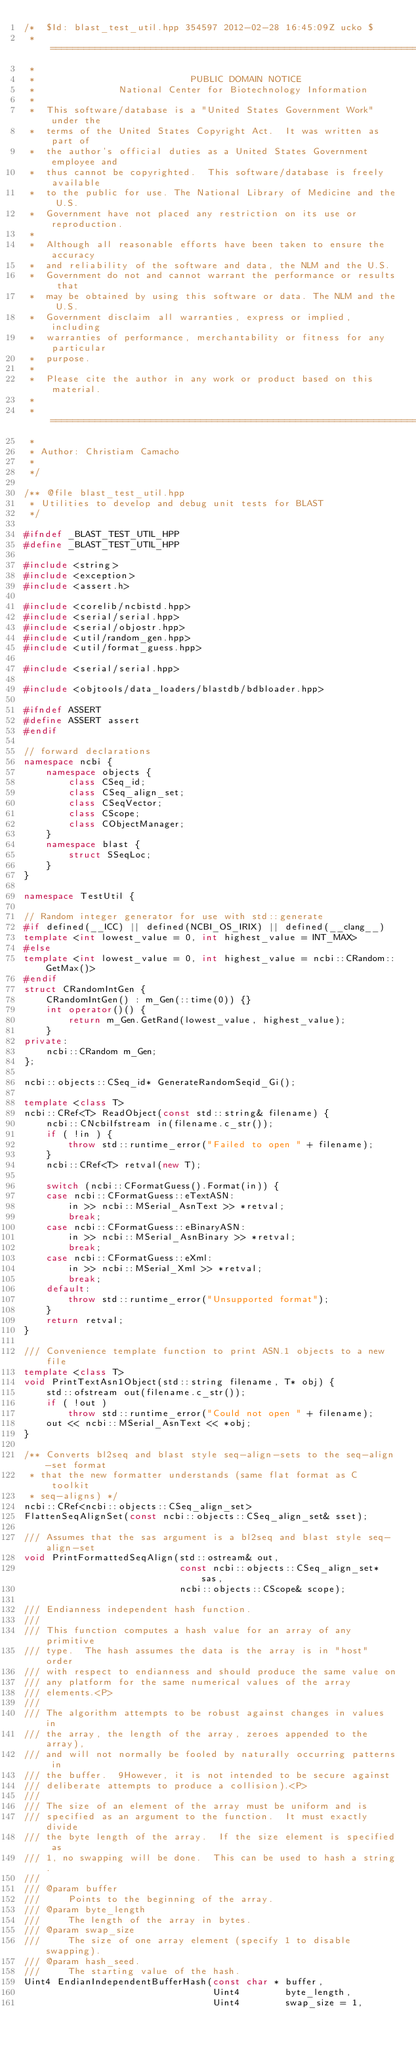Convert code to text. <code><loc_0><loc_0><loc_500><loc_500><_C++_>/*  $Id: blast_test_util.hpp 354597 2012-02-28 16:45:09Z ucko $
 * ===========================================================================
 *
 *                            PUBLIC DOMAIN NOTICE
 *               National Center for Biotechnology Information
 *
 *  This software/database is a "United States Government Work" under the
 *  terms of the United States Copyright Act.  It was written as part of
 *  the author's official duties as a United States Government employee and
 *  thus cannot be copyrighted.  This software/database is freely available
 *  to the public for use. The National Library of Medicine and the U.S.
 *  Government have not placed any restriction on its use or reproduction.
 *
 *  Although all reasonable efforts have been taken to ensure the accuracy
 *  and reliability of the software and data, the NLM and the U.S.
 *  Government do not and cannot warrant the performance or results that
 *  may be obtained by using this software or data. The NLM and the U.S.
 *  Government disclaim all warranties, express or implied, including
 *  warranties of performance, merchantability or fitness for any particular
 *  purpose.
 *
 *  Please cite the author in any work or product based on this material.
 *
 * ===========================================================================
 *
 * Author: Christiam Camacho
 *
 */

/** @file blast_test_util.hpp
 * Utilities to develop and debug unit tests for BLAST
 */

#ifndef _BLAST_TEST_UTIL_HPP
#define _BLAST_TEST_UTIL_HPP

#include <string>
#include <exception>
#include <assert.h>

#include <corelib/ncbistd.hpp>
#include <serial/serial.hpp>
#include <serial/objostr.hpp>
#include <util/random_gen.hpp>
#include <util/format_guess.hpp>

#include <serial/serial.hpp>

#include <objtools/data_loaders/blastdb/bdbloader.hpp>

#ifndef ASSERT
#define ASSERT assert
#endif

// forward declarations
namespace ncbi {
    namespace objects {
        class CSeq_id;
        class CSeq_align_set;
        class CSeqVector;
        class CScope;
        class CObjectManager;
    }
    namespace blast {
        struct SSeqLoc;
    }
}

namespace TestUtil {

// Random integer generator for use with std::generate
#if defined(__ICC) || defined(NCBI_OS_IRIX) || defined(__clang__)
template <int lowest_value = 0, int highest_value = INT_MAX>
#else
template <int lowest_value = 0, int highest_value = ncbi::CRandom::GetMax()>
#endif
struct CRandomIntGen {
    CRandomIntGen() : m_Gen(::time(0)) {}
    int operator()() {
        return m_Gen.GetRand(lowest_value, highest_value);
    }
private:
    ncbi::CRandom m_Gen;
};

ncbi::objects::CSeq_id* GenerateRandomSeqid_Gi();

template <class T>
ncbi::CRef<T> ReadObject(const std::string& filename) {
    ncbi::CNcbiIfstream in(filename.c_str()); 
    if ( !in ) {
        throw std::runtime_error("Failed to open " + filename);
    }
    ncbi::CRef<T> retval(new T);

    switch (ncbi::CFormatGuess().Format(in)) {
    case ncbi::CFormatGuess::eTextASN:
        in >> ncbi::MSerial_AsnText >> *retval;
        break;
    case ncbi::CFormatGuess::eBinaryASN:
        in >> ncbi::MSerial_AsnBinary >> *retval;
        break;
    case ncbi::CFormatGuess::eXml:
        in >> ncbi::MSerial_Xml >> *retval;
        break;
    default:
        throw std::runtime_error("Unsupported format");
    }
    return retval;
}

/// Convenience template function to print ASN.1 objects to a new file
template <class T>
void PrintTextAsn1Object(std::string filename, T* obj) {
    std::ofstream out(filename.c_str());
    if ( !out )
        throw std::runtime_error("Could not open " + filename);
    out << ncbi::MSerial_AsnText << *obj;
}

/** Converts bl2seq and blast style seq-align-sets to the seq-align-set format
 * that the new formatter understands (same flat format as C toolkit
 * seq-aligns) */
ncbi::CRef<ncbi::objects::CSeq_align_set>
FlattenSeqAlignSet(const ncbi::objects::CSeq_align_set& sset);

/// Assumes that the sas argument is a bl2seq and blast style seq-align-set
void PrintFormattedSeqAlign(std::ostream& out,
                            const ncbi::objects::CSeq_align_set* sas,
                            ncbi::objects::CScope& scope);

/// Endianness independent hash function.
///
/// This function computes a hash value for an array of any primitive
/// type.  The hash assumes the data is the array is in "host" order
/// with respect to endianness and should produce the same value on
/// any platform for the same numerical values of the array
/// elements.<P>
///
/// The algorithm attempts to be robust against changes in values in
/// the array, the length of the array, zeroes appended to the array),
/// and will not normally be fooled by naturally occurring patterns in
/// the buffer.  9However, it is not intended to be secure against
/// deliberate attempts to produce a collision).<P>
///
/// The size of an element of the array must be uniform and is
/// specified as an argument to the function.  It must exactly divide
/// the byte length of the array.  If the size element is specified as
/// 1, no swapping will be done.  This can be used to hash a string.
///
/// @param buffer
///     Points to the beginning of the array.
/// @param byte_length
///     The length of the array in bytes.
/// @param swap_size
///     The size of one array element (specify 1 to disable swapping).
/// @param hash_seed.
///     The starting value of the hash.
Uint4 EndianIndependentBufferHash(const char * buffer,
                                  Uint4        byte_length,
                                  Uint4        swap_size = 1,</code> 